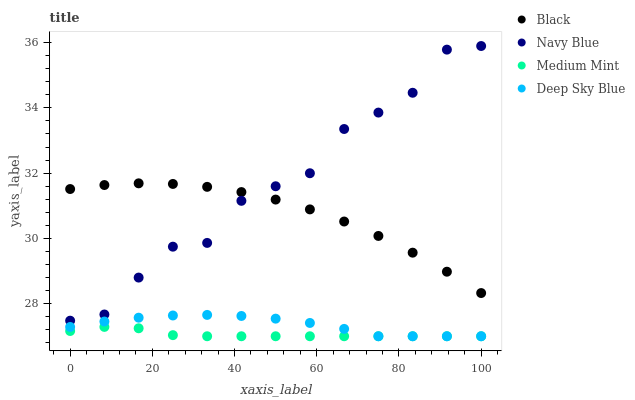Does Medium Mint have the minimum area under the curve?
Answer yes or no. Yes. Does Navy Blue have the maximum area under the curve?
Answer yes or no. Yes. Does Black have the minimum area under the curve?
Answer yes or no. No. Does Black have the maximum area under the curve?
Answer yes or no. No. Is Medium Mint the smoothest?
Answer yes or no. Yes. Is Navy Blue the roughest?
Answer yes or no. Yes. Is Black the smoothest?
Answer yes or no. No. Is Black the roughest?
Answer yes or no. No. Does Medium Mint have the lowest value?
Answer yes or no. Yes. Does Navy Blue have the lowest value?
Answer yes or no. No. Does Navy Blue have the highest value?
Answer yes or no. Yes. Does Black have the highest value?
Answer yes or no. No. Is Deep Sky Blue less than Black?
Answer yes or no. Yes. Is Navy Blue greater than Medium Mint?
Answer yes or no. Yes. Does Navy Blue intersect Black?
Answer yes or no. Yes. Is Navy Blue less than Black?
Answer yes or no. No. Is Navy Blue greater than Black?
Answer yes or no. No. Does Deep Sky Blue intersect Black?
Answer yes or no. No. 